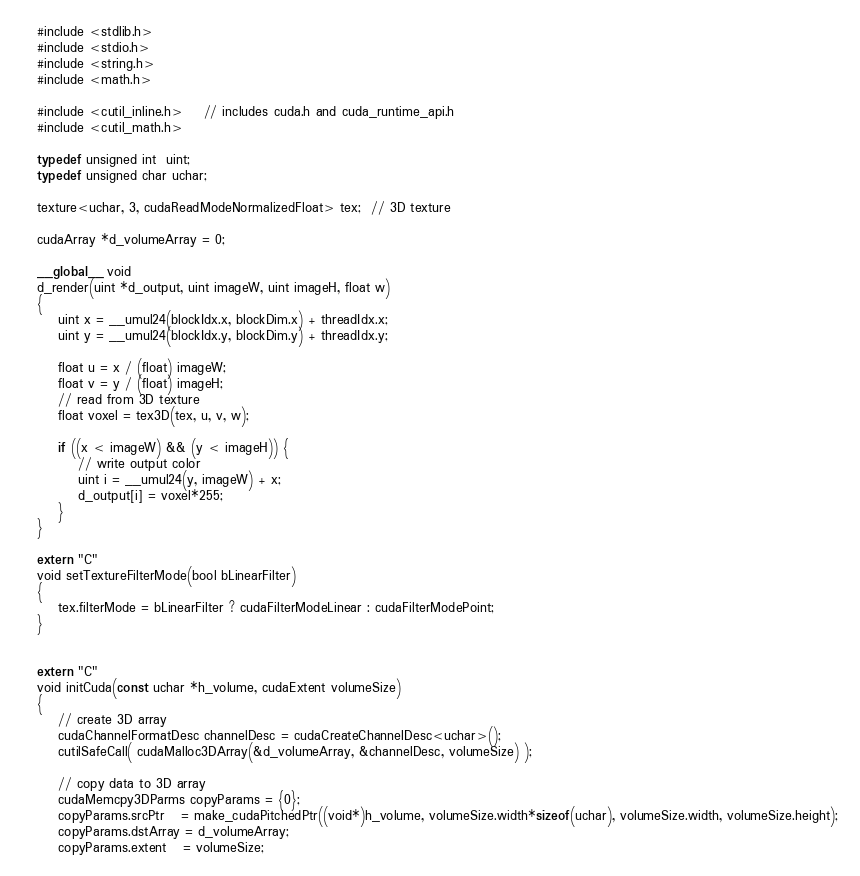<code> <loc_0><loc_0><loc_500><loc_500><_Cuda_>#include <stdlib.h>
#include <stdio.h>
#include <string.h>
#include <math.h>

#include <cutil_inline.h>    // includes cuda.h and cuda_runtime_api.h
#include <cutil_math.h>

typedef unsigned int  uint;
typedef unsigned char uchar;

texture<uchar, 3, cudaReadModeNormalizedFloat> tex;  // 3D texture

cudaArray *d_volumeArray = 0;

__global__ void
d_render(uint *d_output, uint imageW, uint imageH, float w)
{
	uint x = __umul24(blockIdx.x, blockDim.x) + threadIdx.x;
    uint y = __umul24(blockIdx.y, blockDim.y) + threadIdx.y;

    float u = x / (float) imageW;
    float v = y / (float) imageH;
    // read from 3D texture
    float voxel = tex3D(tex, u, v, w);

    if ((x < imageW) && (y < imageH)) {
        // write output color
        uint i = __umul24(y, imageW) + x;
        d_output[i] = voxel*255;
    }
}

extern "C"
void setTextureFilterMode(bool bLinearFilter)
{
    tex.filterMode = bLinearFilter ? cudaFilterModeLinear : cudaFilterModePoint;
}


extern "C"
void initCuda(const uchar *h_volume, cudaExtent volumeSize)
{
    // create 3D array
    cudaChannelFormatDesc channelDesc = cudaCreateChannelDesc<uchar>();
    cutilSafeCall( cudaMalloc3DArray(&d_volumeArray, &channelDesc, volumeSize) );

    // copy data to 3D array
    cudaMemcpy3DParms copyParams = {0};
    copyParams.srcPtr   = make_cudaPitchedPtr((void*)h_volume, volumeSize.width*sizeof(uchar), volumeSize.width, volumeSize.height);
    copyParams.dstArray = d_volumeArray;
    copyParams.extent   = volumeSize;</code> 